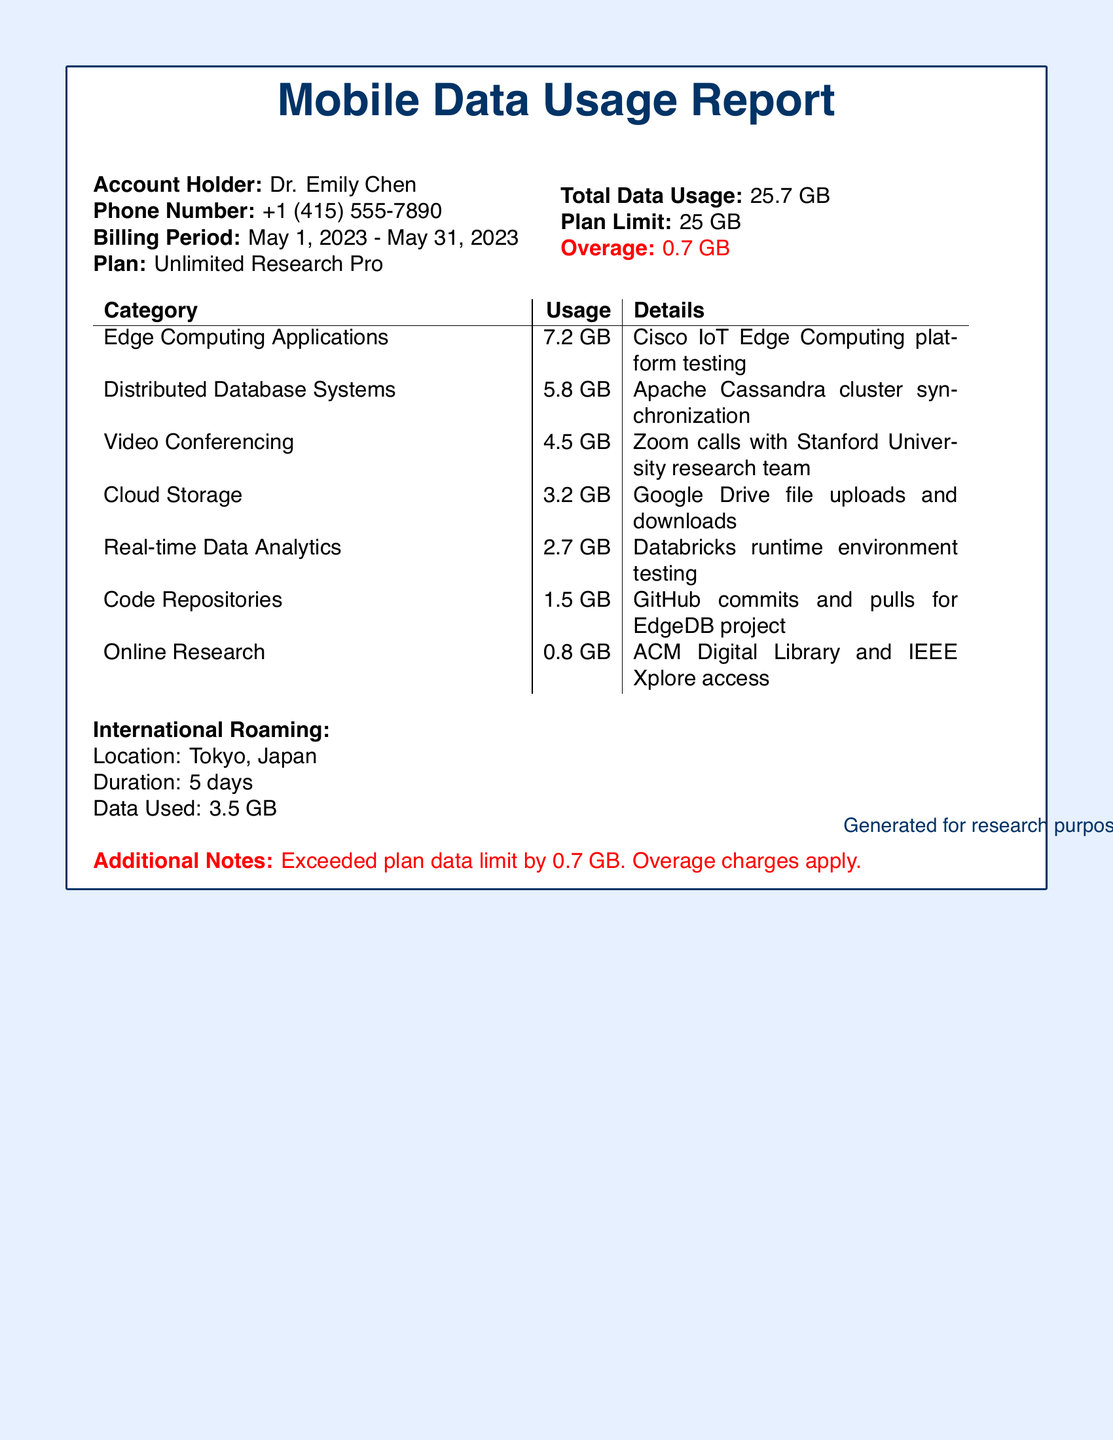What is the account holder's name? The account holder's name is stated at the beginning of the report.
Answer: Dr. Emily Chen What is the billing period for the mobile plan? The billing period is specified in the document.
Answer: May 1, 2023 - May 31, 2023 What is the total data usage reported? The document clearly indicates the total data usage amount.
Answer: 25.7 GB What is the overage data amount? The overage amount is highlighted in red in the document.
Answer: 0.7 GB How much data was used for Edge Computing Applications? The document lists the specific data usage for each category.
Answer: 7.2 GB What was the duration of international roaming? The duration of international roaming is specified in the report.
Answer: 5 days What was the location of international roaming? The document provides this information under the international roaming section.
Answer: Tokyo, Japan How much data was used for Cloud Storage? The usage for Cloud Storage is detailed in the data usage table.
Answer: 3.2 GB What type of mobile plan is being used? The type of mobile plan is indicated in the summary.
Answer: Unlimited Research Pro 